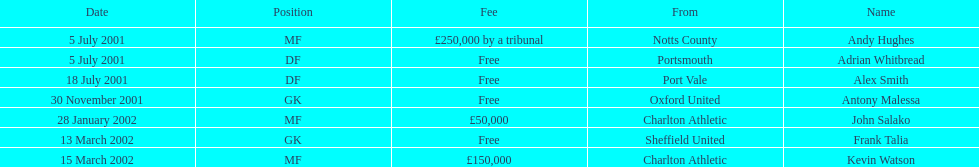What was the transfer fee to transfer kevin watson? £150,000. 